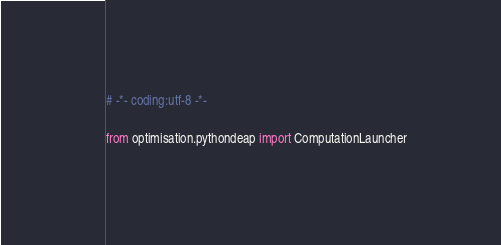Convert code to text. <code><loc_0><loc_0><loc_500><loc_500><_Python_># -*- coding:utf-8 -*-

from optimisation.pythondeap import ComputationLauncher
</code> 